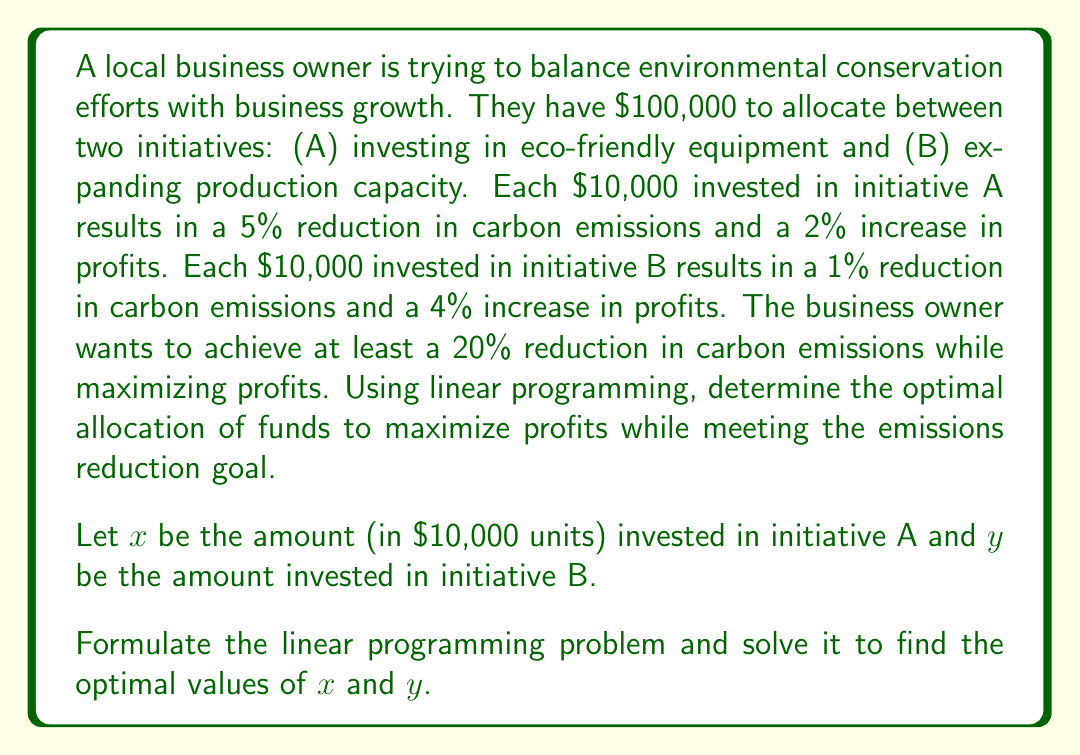Could you help me with this problem? To solve this linear programming problem, we need to follow these steps:

1. Define the objective function
2. Identify the constraints
3. Set up the linear programming problem
4. Solve the problem using the graphical method or simplex algorithm

Step 1: Define the objective function
The objective is to maximize profits. 
Profit increase = $2x + 4y$ (in percentage)
Objective function: Maximize $Z = 2x + 4y$

Step 2: Identify the constraints
a) Budget constraint: $10,000x + 10,000y \leq 100,000$
   Simplified: $x + y \leq 10$

b) Emissions reduction constraint: $5x + y \geq 20$

c) Non-negativity constraints: $x \geq 0$, $y \geq 0$

Step 3: Set up the linear programming problem
Maximize $Z = 2x + 4y$
Subject to:
$x + y \leq 10$
$5x + y \geq 20$
$x \geq 0$, $y \geq 0$

Step 4: Solve the problem using the graphical method
We can solve this problem graphically by plotting the constraints and finding the feasible region.

[asy]
import geometry;

size(200);

// Define axes
draw((-1,0)--(11,0), arrow=Arrow);
draw((0,-1)--(0,11), arrow=Arrow);

// Label axes
label("x", (11,0), E);
label("y", (0,11), N);

// Plot constraints
draw((0,10)--(10,0), blue);
draw((4,0)--(0,20), red);

// Shade feasible region
fill((4,0)--(4,6)--(6,4)--(10,0)--cycle, palegreen);

// Label points
dot((4,6));
dot((6,4));

label("(4,6)", (4,6), NE);
label("(6,4)", (6,4), SE);

// Label lines
label("x + y = 10", (5,5), NW, blue);
label("5x + y = 20", (2,10), NW, red);
[/asy]

The feasible region is the shaded area. The optimal solution will be at one of the corner points of this region. We need to evaluate the objective function at these points:

Point (4, 6): $Z = 2(4) + 4(6) = 32$
Point (6, 4): $Z = 2(6) + 4(4) = 28$

The maximum value of Z occurs at the point (4, 6).

Therefore, the optimal solution is:
$x = 4$ (invest $40,000 in initiative A)
$y = 6$ (invest $60,000 in initiative B)

This allocation will result in a profit increase of 32% while meeting the emissions reduction goal of at least 20%.
Answer: The optimal allocation is to invest $40,000 in eco-friendly equipment (initiative A) and $60,000 in expanding production capacity (initiative B). This will maximize profits with a 32% increase while achieving a 26% reduction in carbon emissions. 